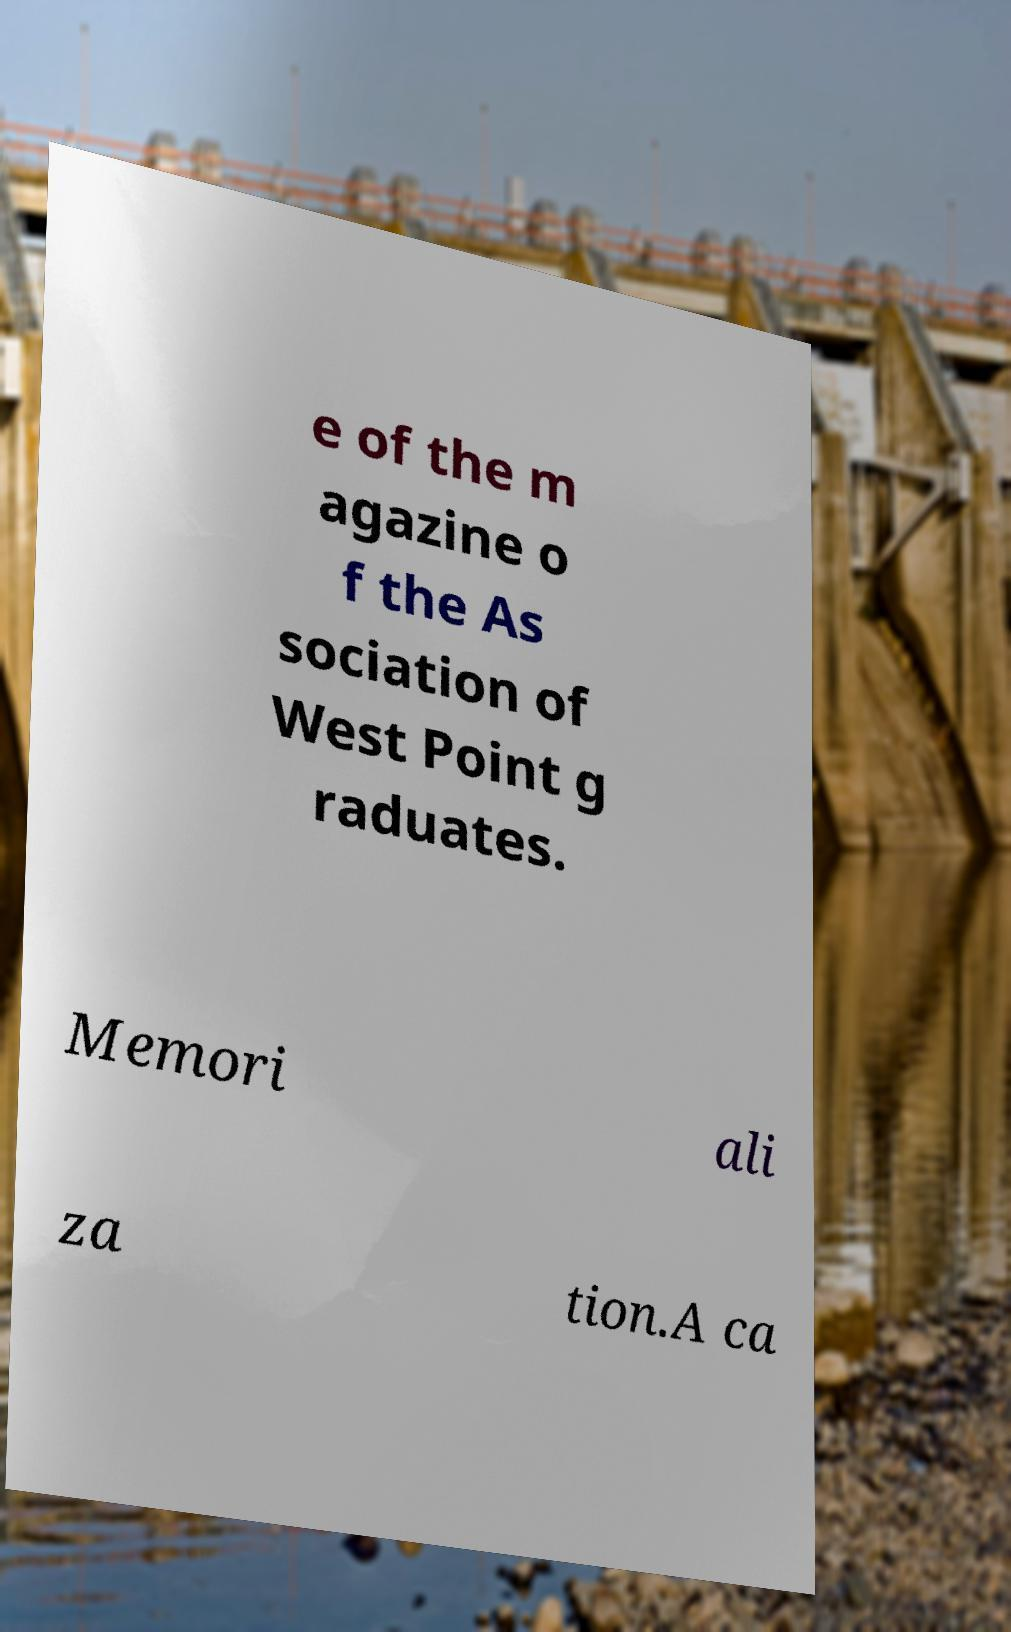Please read and relay the text visible in this image. What does it say? e of the m agazine o f the As sociation of West Point g raduates. Memori ali za tion.A ca 